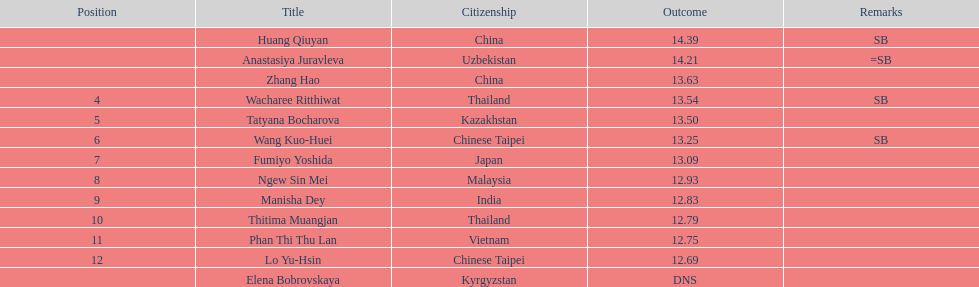I'm looking to parse the entire table for insights. Could you assist me with that? {'header': ['Position', 'Title', 'Citizenship', 'Outcome', 'Remarks'], 'rows': [['', 'Huang Qiuyan', 'China', '14.39', 'SB'], ['', 'Anastasiya Juravleva', 'Uzbekistan', '14.21', '=SB'], ['', 'Zhang Hao', 'China', '13.63', ''], ['4', 'Wacharee Ritthiwat', 'Thailand', '13.54', 'SB'], ['5', 'Tatyana Bocharova', 'Kazakhstan', '13.50', ''], ['6', 'Wang Kuo-Huei', 'Chinese Taipei', '13.25', 'SB'], ['7', 'Fumiyo Yoshida', 'Japan', '13.09', ''], ['8', 'Ngew Sin Mei', 'Malaysia', '12.93', ''], ['9', 'Manisha Dey', 'India', '12.83', ''], ['10', 'Thitima Muangjan', 'Thailand', '12.79', ''], ['11', 'Phan Thi Thu Lan', 'Vietnam', '12.75', ''], ['12', 'Lo Yu-Hsin', 'Chinese Taipei', '12.69', ''], ['', 'Elena Bobrovskaya', 'Kyrgyzstan', 'DNS', '']]} What is the number of athletes who performed better than tatyana bocharova? 4. 